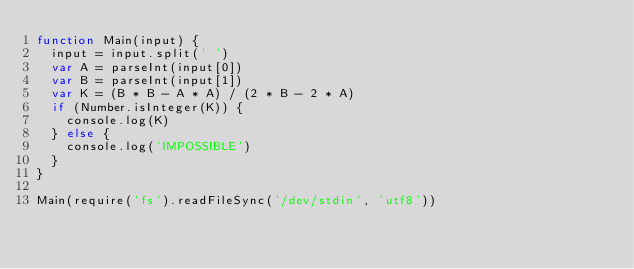<code> <loc_0><loc_0><loc_500><loc_500><_JavaScript_>function Main(input) {
  input = input.split(' ')
  var A = parseInt(input[0])
  var B = parseInt(input[1])
  var K = (B * B - A * A) / (2 * B - 2 * A)
  if (Number.isInteger(K)) {
    console.log(K)
  } else {
    console.log('IMPOSSIBLE')
  }
}

Main(require('fs').readFileSync('/dev/stdin', 'utf8'))

</code> 